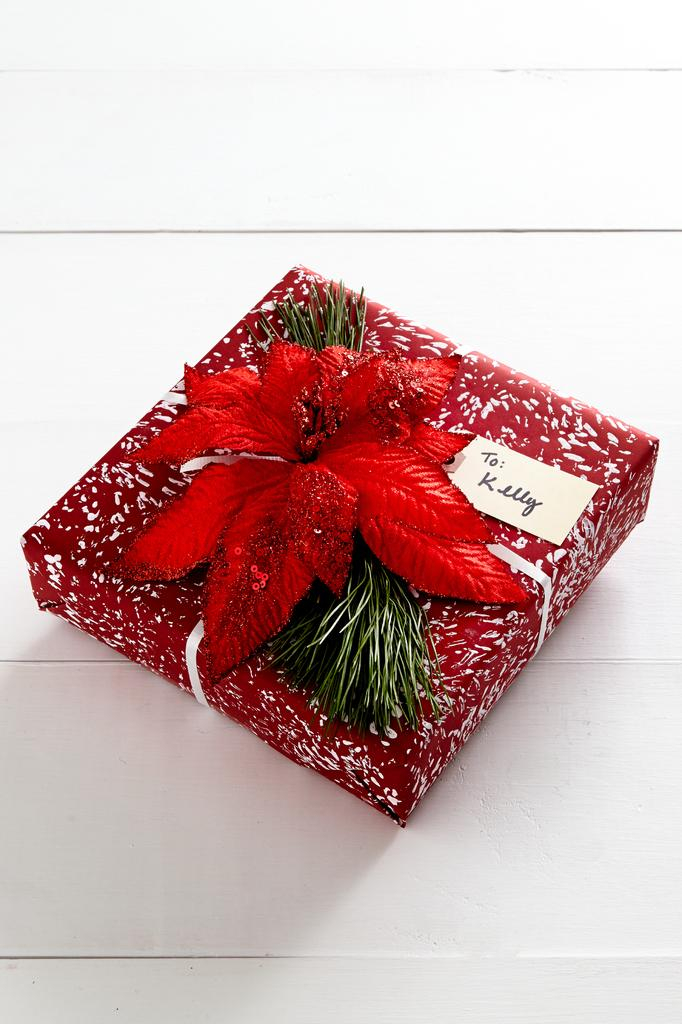What is the main object in the middle of the image? There is a gift box in the middle of the image. What decoration is on the gift box? The gift box has a red color flower on it. Is there any written message or note on the gift box? There is a card on the gift box. On what surface is the gift box placed? The gift box is on a surface. What is the color of the background in the image? The background of the image is white in color. What type of ice can be seen melting on the gift box in the image? There is no ice present on the gift box or in the image. 